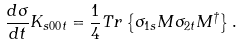Convert formula to latex. <formula><loc_0><loc_0><loc_500><loc_500>\frac { d \sigma } { d t } K _ { s 0 0 t } = \frac { 1 } { 4 } T r \left \{ \sigma _ { 1 s } M \sigma _ { 2 t } M ^ { \dagger } \right \} .</formula> 